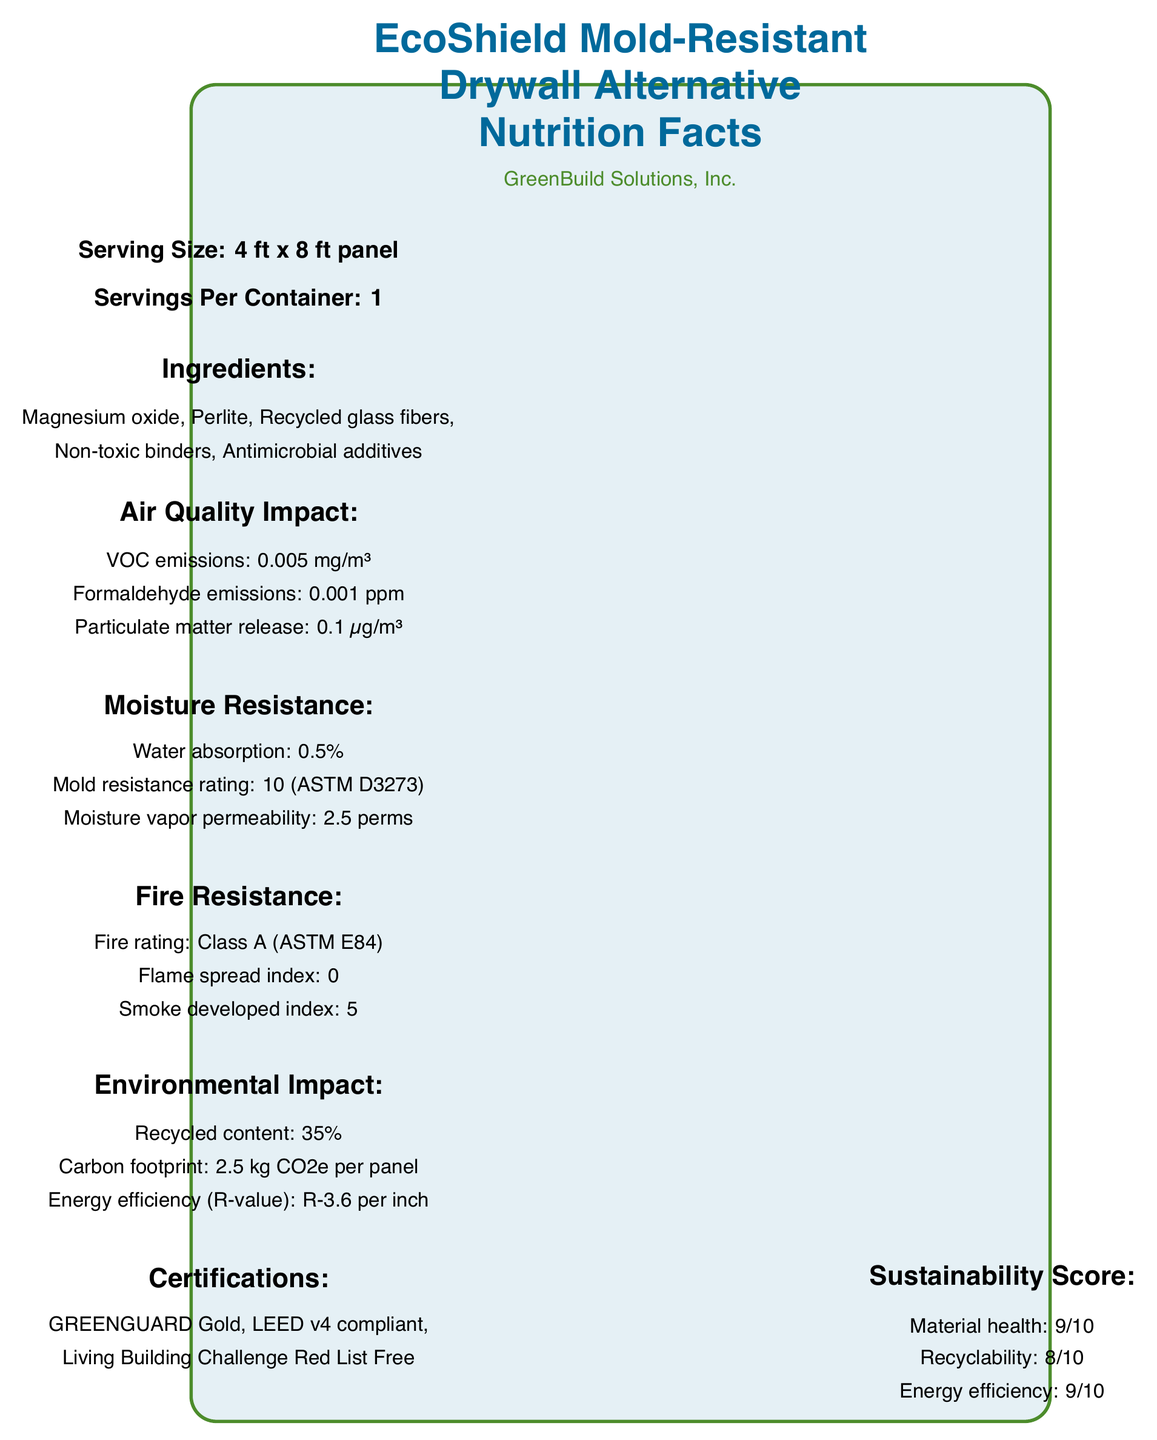what is the serving size of the EcoShield Mold-Resistant Drywall Alternative? The serving size is mentioned under the Serving Size section as "4 ft x 8 ft panel".
Answer: 4 ft x 8 ft panel which company manufactures the EcoShield Mold-Resistant Drywall Alternative? The manufacturer is listed right below the title as "GreenBuild Solutions, Inc."
Answer: GreenBuild Solutions, Inc. what is the mold resistance rating of the product? The mold resistance rating is mentioned under the Moisture Resistance section as "10 (ASTM D3273)".
Answer: 10 (ASTM D3273) how much recycled content does the product contain? The recycled content is specified under the Environmental Impact section as "Recycled content: 35%".
Answer: 35% what is the flame spread index of the EcoShield product? The flame spread index is mentioned under the Fire Resistance section as "Flame spread index: 0".
Answer: 0 how much water absorption does this drywall have? The water absorption is specified under the Moisture Resistance section as "Water absorption: 0.5%".
Answer: 0.5% what certifications does the EcoShield product hold? The certifications are listed under the Certifications section.
Answer: GREENGUARD Gold, LEED v4 compliant, Living Building Challenge Red List Free what is the formaldehyde emission level of this product? The formaldehyde emissions are mentioned under the Air Quality Impact section as "Formaldehyde emissions: 0.001 ppm".
Answer: 0.001 ppm what type of fasteners are recommended for installation? The recommended fasteners are listed under the Installation Guidelines section as "Corrosion-resistant screws".
Answer: Corrosion-resistant screws describe the main idea of this document. The document is structured to give a comprehensive overview of the EcoShield Mold-Resistant Drywall Alternative, highlighting its benefits, certifications, and suitability for different building requirements.
Answer: The document provides detailed information about the EcoShield Mold-Resistant Drywall Alternative, including its serving size, ingredients, air quality impact, moisture resistance, fire resistance, environmental impact, certifications, sustainability score, and installation guidelines. It also mentions the product's disaster resilience features, indoor air quality benefits, and compliance with various building codes. what is the energy efficiency R-value per inch of the EcoShield panel? The energy efficiency is listed under the Environmental Impact section as "Energy efficiency (R-value): R-3.6 per inch".
Answer: R-3.6 per inch what fire rating does the product have? The fire rating is mentioned under the Fire Resistance section as "Fire rating: Class A (ASTM E84)".
Answer: Class A (ASTM E84) how many servings per container does the product offer? Under the Serving Information section, it states "Servings Per Container: 1".
Answer: 1 what is the smoke developed index for the product? A. 0 B. 5 C. 10 D. 15 The smoke developed index is under the Fire Resistance section as "Smoke developed index: 5".
Answer: B. 5 what are the moisture vapor permeability properties of the product? A. 0 perms B. 2.5 perms C. 5 perms D. 10 perms The moisture vapor permeability is listed under the Moisture Resistance section as "Moisture vapor permeability: 2.5 perms".
Answer: B. 2.5 perms what company produces the EcoShield product? A. BuildRight Corp. B. GreenBuild Solutions, Inc. C. EcoMaterials Ltd. D. HomeSafe Solutions The manufacturer is mentioned below the title as "GreenBuild Solutions, Inc."
Answer: B. GreenBuild Solutions, Inc. does the EcoShield drywall inhibit the growth of common indoor allergens? Under the Indoor Air Quality Benefits section, it mentions "Inhibits growth of common indoor allergens".
Answer: Yes can the document provide information on the cost of the EcoShield drywall per panel? The document does not include any information about the cost or pricing of the EcoShield drywall per panel.
Answer: Cannot be determined 